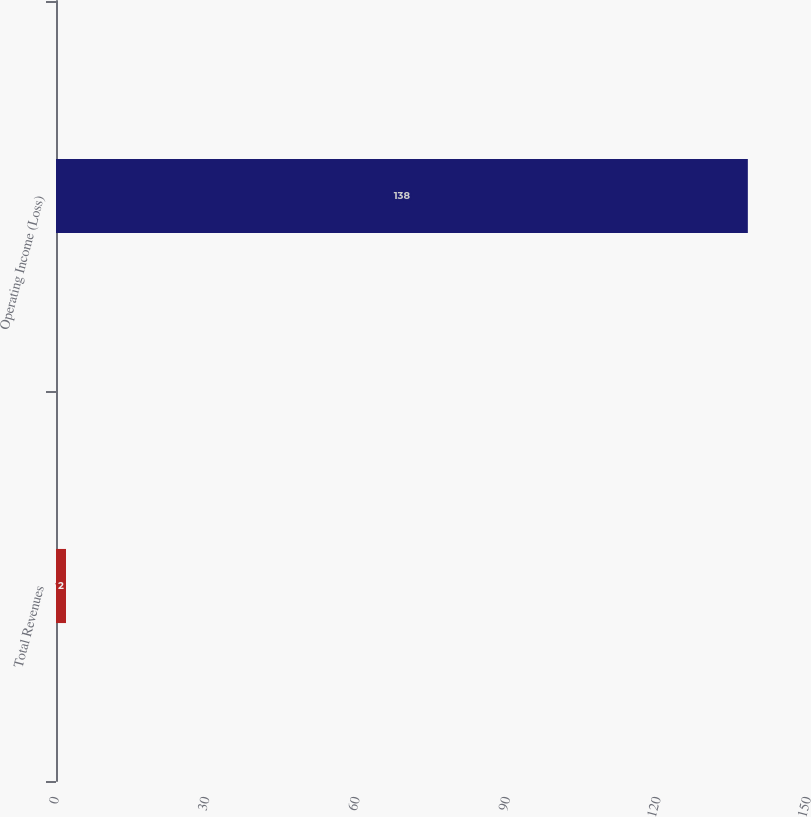Convert chart. <chart><loc_0><loc_0><loc_500><loc_500><bar_chart><fcel>Total Revenues<fcel>Operating Income (Loss)<nl><fcel>2<fcel>138<nl></chart> 